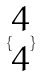<formula> <loc_0><loc_0><loc_500><loc_500>\{ \begin{matrix} 4 \\ 4 \end{matrix} \}</formula> 